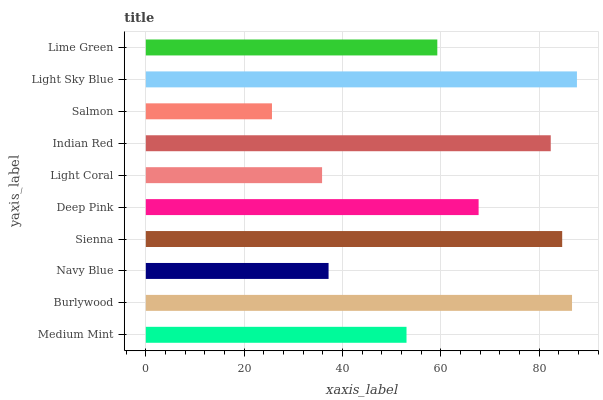Is Salmon the minimum?
Answer yes or no. Yes. Is Light Sky Blue the maximum?
Answer yes or no. Yes. Is Burlywood the minimum?
Answer yes or no. No. Is Burlywood the maximum?
Answer yes or no. No. Is Burlywood greater than Medium Mint?
Answer yes or no. Yes. Is Medium Mint less than Burlywood?
Answer yes or no. Yes. Is Medium Mint greater than Burlywood?
Answer yes or no. No. Is Burlywood less than Medium Mint?
Answer yes or no. No. Is Deep Pink the high median?
Answer yes or no. Yes. Is Lime Green the low median?
Answer yes or no. Yes. Is Medium Mint the high median?
Answer yes or no. No. Is Light Coral the low median?
Answer yes or no. No. 